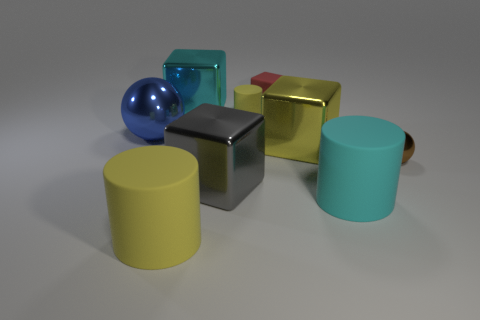Add 1 big gray shiny cubes. How many objects exist? 10 Subtract all cubes. How many objects are left? 5 Add 4 tiny brown spheres. How many tiny brown spheres exist? 5 Subtract 1 red blocks. How many objects are left? 8 Subtract all yellow blocks. Subtract all cylinders. How many objects are left? 5 Add 7 tiny balls. How many tiny balls are left? 8 